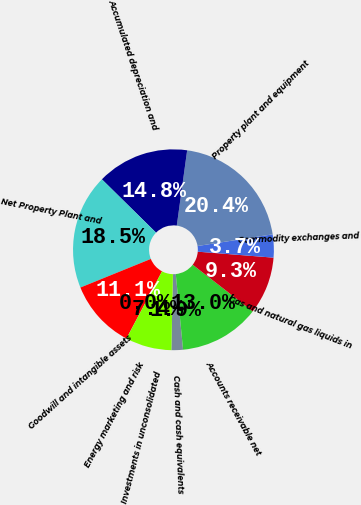Convert chart. <chart><loc_0><loc_0><loc_500><loc_500><pie_chart><fcel>Cash and cash equivalents<fcel>Accounts receivable net<fcel>Gas and natural gas liquids in<fcel>Commodity exchanges and<fcel>Property plant and equipment<fcel>Accumulated depreciation and<fcel>Net Property Plant and<fcel>Goodwill and intangible assets<fcel>Energy marketing and risk<fcel>Investments in unconsolidated<nl><fcel>1.86%<fcel>12.96%<fcel>9.26%<fcel>3.71%<fcel>20.36%<fcel>14.81%<fcel>18.51%<fcel>11.11%<fcel>0.01%<fcel>7.41%<nl></chart> 